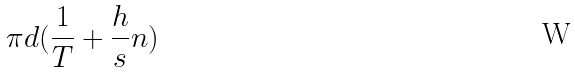<formula> <loc_0><loc_0><loc_500><loc_500>\pi d ( \frac { 1 } { T } + \frac { h } { s } n )</formula> 